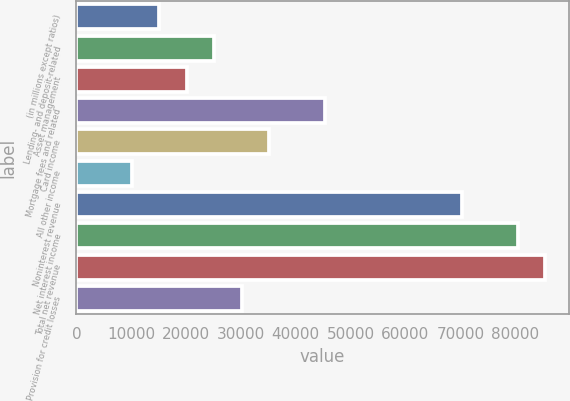Convert chart. <chart><loc_0><loc_0><loc_500><loc_500><bar_chart><fcel>(in millions except ratios)<fcel>Lending- and deposit-related<fcel>Asset management<fcel>Mortgage fees and related<fcel>Card income<fcel>All other income<fcel>Noninterest revenue<fcel>Net interest income<fcel>Total net revenue<fcel>Provision for credit losses<nl><fcel>15100.9<fcel>25151.5<fcel>20126.2<fcel>45252.7<fcel>35202.1<fcel>10075.6<fcel>70379.2<fcel>80429.8<fcel>85455.1<fcel>30176.8<nl></chart> 